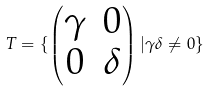Convert formula to latex. <formula><loc_0><loc_0><loc_500><loc_500>T = \{ \begin{pmatrix} \gamma & 0 \\ 0 & \delta \end{pmatrix} | \gamma \delta \neq 0 \}</formula> 